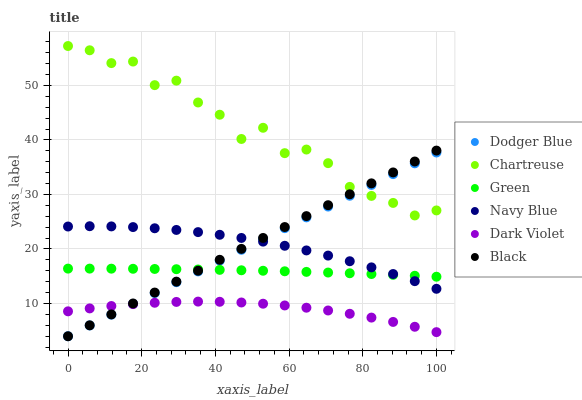Does Dark Violet have the minimum area under the curve?
Answer yes or no. Yes. Does Chartreuse have the maximum area under the curve?
Answer yes or no. Yes. Does Chartreuse have the minimum area under the curve?
Answer yes or no. No. Does Dark Violet have the maximum area under the curve?
Answer yes or no. No. Is Dodger Blue the smoothest?
Answer yes or no. Yes. Is Chartreuse the roughest?
Answer yes or no. Yes. Is Dark Violet the smoothest?
Answer yes or no. No. Is Dark Violet the roughest?
Answer yes or no. No. Does Black have the lowest value?
Answer yes or no. Yes. Does Dark Violet have the lowest value?
Answer yes or no. No. Does Chartreuse have the highest value?
Answer yes or no. Yes. Does Dark Violet have the highest value?
Answer yes or no. No. Is Dark Violet less than Green?
Answer yes or no. Yes. Is Chartreuse greater than Navy Blue?
Answer yes or no. Yes. Does Green intersect Navy Blue?
Answer yes or no. Yes. Is Green less than Navy Blue?
Answer yes or no. No. Is Green greater than Navy Blue?
Answer yes or no. No. Does Dark Violet intersect Green?
Answer yes or no. No. 